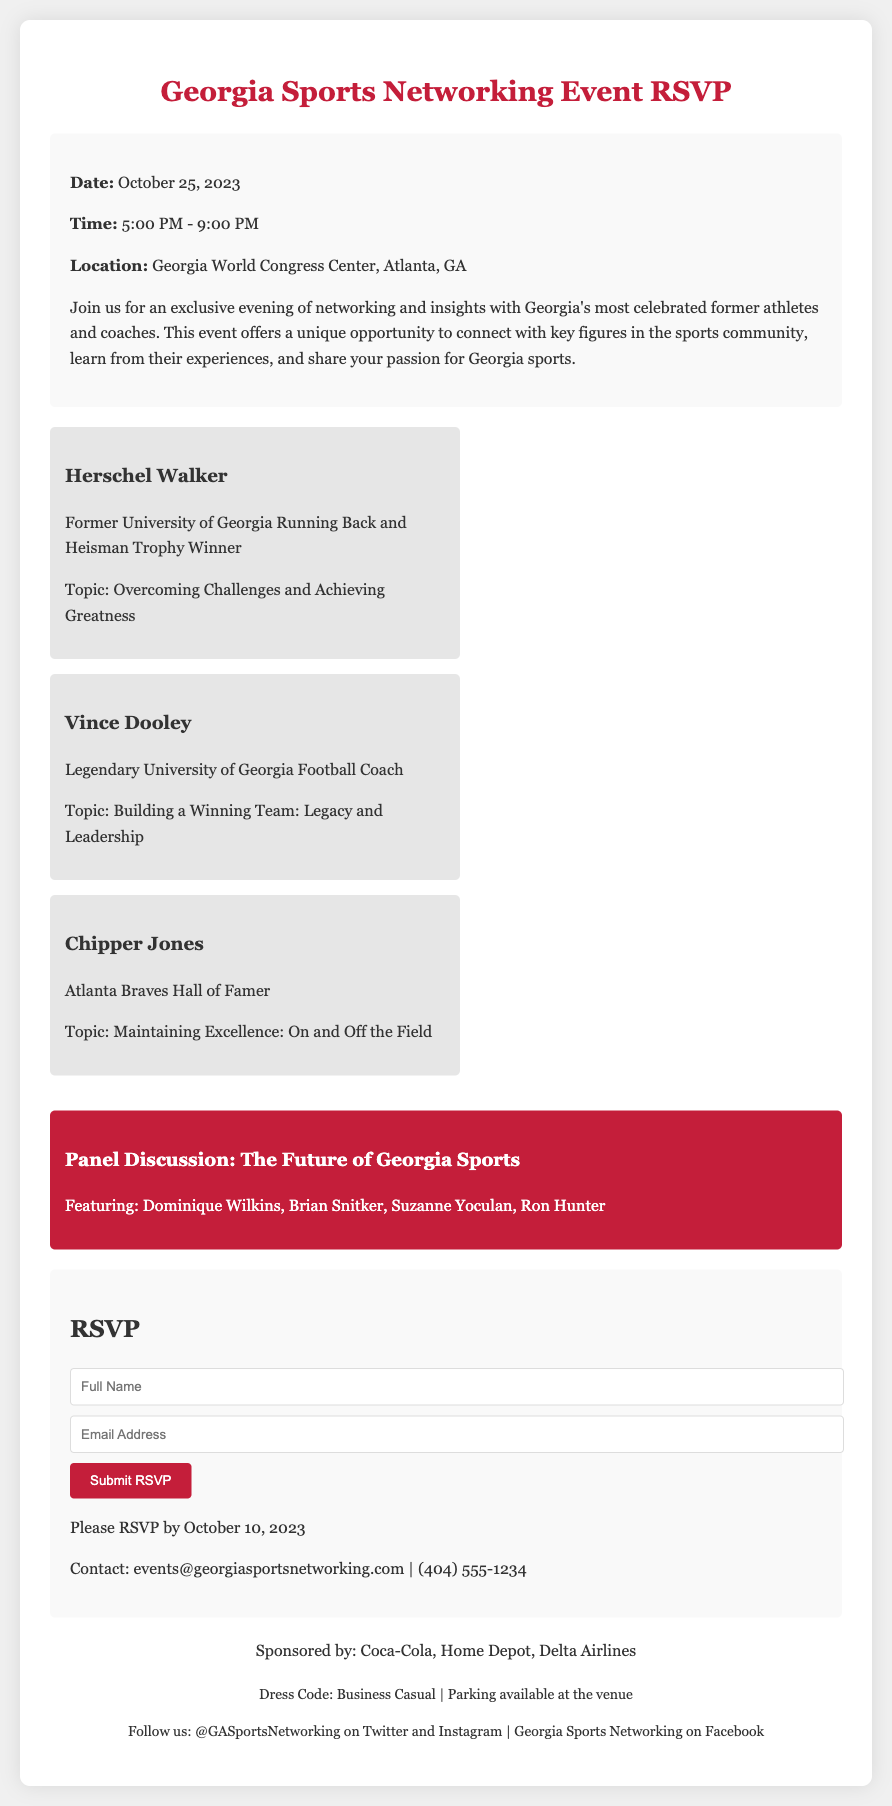What is the date of the event? The date of the event is clearly stated in the document as October 25, 2023.
Answer: October 25, 2023 What is the location of the event? The document mentions that the event will take place at the Georgia World Congress Center, Atlanta, GA.
Answer: Georgia World Congress Center, Atlanta, GA Who is a featured speaker at the event? The document lists several renowned former athletes and coaches, one of whom is Herschel Walker.
Answer: Herschel Walker What is the RSVP deadline? The RSVP deadline is specifically indicated in the document as October 10, 2023.
Answer: October 10, 2023 What is the dress code for the event? The document provides a specific dress code as Business Casual.
Answer: Business Casual What time does the event start? The event time is stated in the details, with the starting time being 5:00 PM.
Answer: 5:00 PM How many sponsors are mentioned? The document lists three sponsors: Coca-Cola, Home Depot, and Delta Airlines.
Answer: Three What is the topic of discussion in the panel? The panel discussion is titled "The Future of Georgia Sports," as stated in the document.
Answer: The Future of Georgia Sports Who is the legendary University of Georgia football coach mentioned? The document identifies Vince Dooley as the legendary University of Georgia football coach featured.
Answer: Vince Dooley 